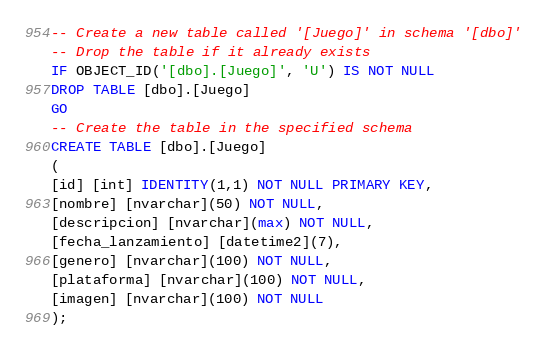<code> <loc_0><loc_0><loc_500><loc_500><_SQL_>-- Create a new table called '[Juego]' in schema '[dbo]'
-- Drop the table if it already exists
IF OBJECT_ID('[dbo].[Juego]', 'U') IS NOT NULL
DROP TABLE [dbo].[Juego]
GO
-- Create the table in the specified schema
CREATE TABLE [dbo].[Juego]
(
[id] [int] IDENTITY(1,1) NOT NULL PRIMARY KEY,
[nombre] [nvarchar](50) NOT NULL,
[descripcion] [nvarchar](max) NOT NULL,
[fecha_lanzamiento] [datetime2](7),
[genero] [nvarchar](100) NOT NULL,
[plataforma] [nvarchar](100) NOT NULL,
[imagen] [nvarchar](100) NOT NULL
);</code> 